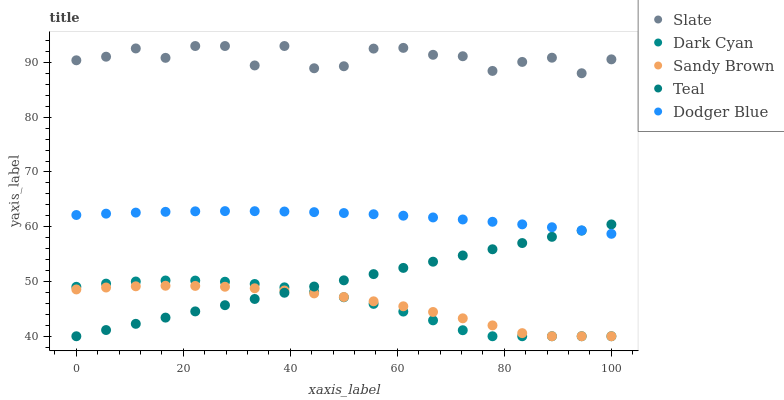Does Dark Cyan have the minimum area under the curve?
Answer yes or no. Yes. Does Slate have the maximum area under the curve?
Answer yes or no. Yes. Does Dodger Blue have the minimum area under the curve?
Answer yes or no. No. Does Dodger Blue have the maximum area under the curve?
Answer yes or no. No. Is Teal the smoothest?
Answer yes or no. Yes. Is Slate the roughest?
Answer yes or no. Yes. Is Dodger Blue the smoothest?
Answer yes or no. No. Is Dodger Blue the roughest?
Answer yes or no. No. Does Dark Cyan have the lowest value?
Answer yes or no. Yes. Does Dodger Blue have the lowest value?
Answer yes or no. No. Does Slate have the highest value?
Answer yes or no. Yes. Does Dodger Blue have the highest value?
Answer yes or no. No. Is Teal less than Slate?
Answer yes or no. Yes. Is Slate greater than Teal?
Answer yes or no. Yes. Does Sandy Brown intersect Teal?
Answer yes or no. Yes. Is Sandy Brown less than Teal?
Answer yes or no. No. Is Sandy Brown greater than Teal?
Answer yes or no. No. Does Teal intersect Slate?
Answer yes or no. No. 